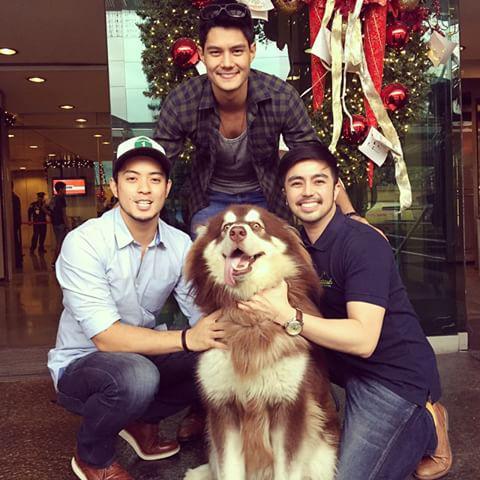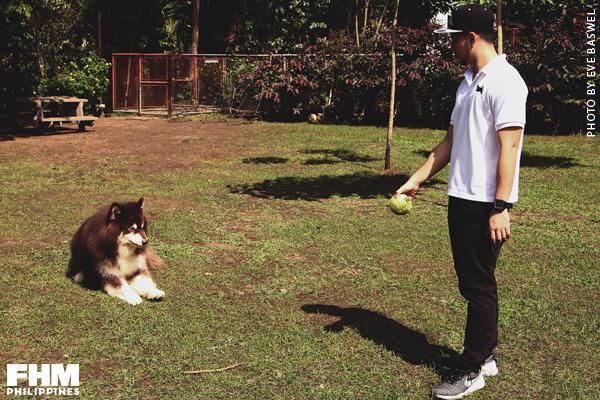The first image is the image on the left, the second image is the image on the right. Analyze the images presented: Is the assertion "The left image features at least two people and at least one open-mouthed dog, and they are posed with three of their heads in a row." valid? Answer yes or no. Yes. The first image is the image on the left, the second image is the image on the right. Assess this claim about the two images: "Three people are sitting and posing for a portrait with a Malamute.". Correct or not? Answer yes or no. Yes. 